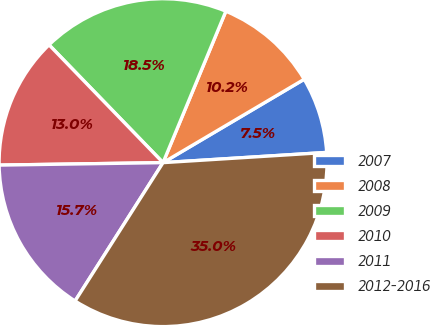<chart> <loc_0><loc_0><loc_500><loc_500><pie_chart><fcel>2007<fcel>2008<fcel>2009<fcel>2010<fcel>2011<fcel>2012-2016<nl><fcel>7.5%<fcel>10.25%<fcel>18.5%<fcel>13.0%<fcel>15.75%<fcel>35.01%<nl></chart> 